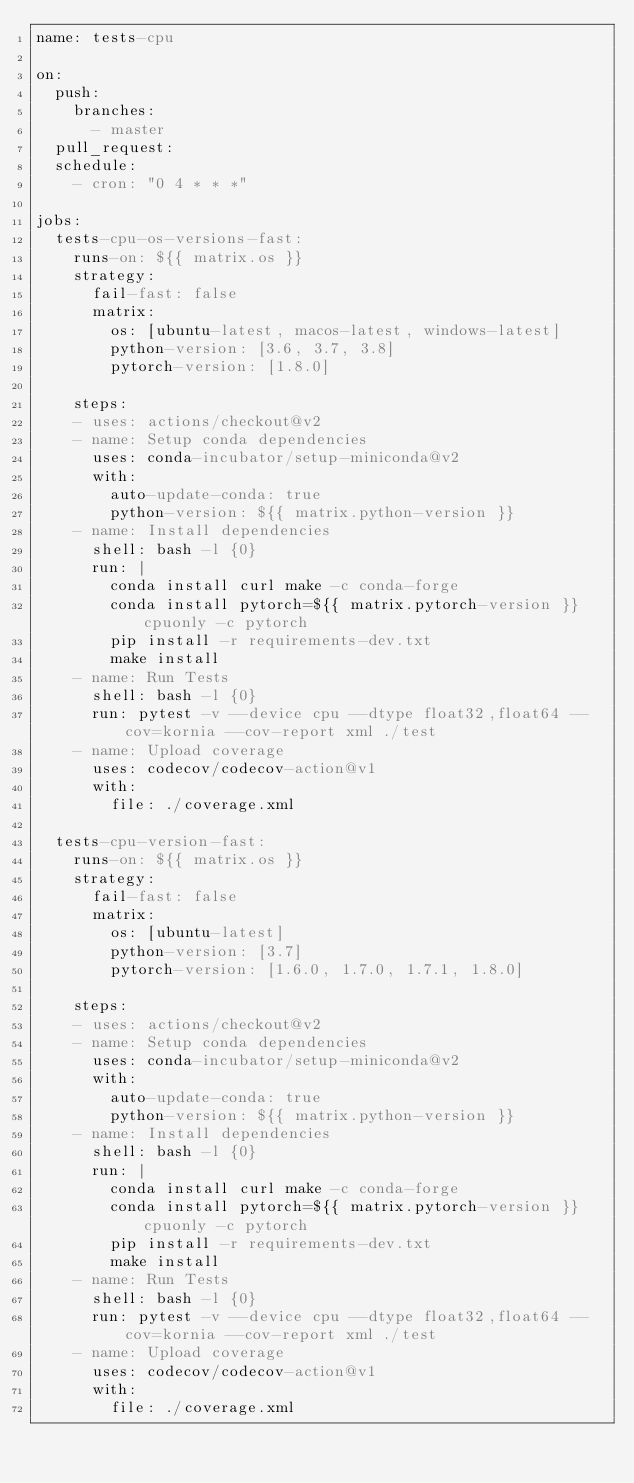Convert code to text. <code><loc_0><loc_0><loc_500><loc_500><_YAML_>name: tests-cpu

on:
  push:
    branches:
      - master
  pull_request:
  schedule:
    - cron: "0 4 * * *"

jobs:
  tests-cpu-os-versions-fast:
    runs-on: ${{ matrix.os }}
    strategy:
      fail-fast: false
      matrix:
        os: [ubuntu-latest, macos-latest, windows-latest]
        python-version: [3.6, 3.7, 3.8]
        pytorch-version: [1.8.0]

    steps:
    - uses: actions/checkout@v2
    - name: Setup conda dependencies
      uses: conda-incubator/setup-miniconda@v2
      with:
        auto-update-conda: true
        python-version: ${{ matrix.python-version }}
    - name: Install dependencies
      shell: bash -l {0}
      run: |
        conda install curl make -c conda-forge
        conda install pytorch=${{ matrix.pytorch-version }} cpuonly -c pytorch
        pip install -r requirements-dev.txt
        make install
    - name: Run Tests
      shell: bash -l {0}
      run: pytest -v --device cpu --dtype float32,float64 --cov=kornia --cov-report xml ./test
    - name: Upload coverage
      uses: codecov/codecov-action@v1
      with:
        file: ./coverage.xml

  tests-cpu-version-fast:
    runs-on: ${{ matrix.os }}
    strategy:
      fail-fast: false
      matrix:
        os: [ubuntu-latest]
        python-version: [3.7]
        pytorch-version: [1.6.0, 1.7.0, 1.7.1, 1.8.0]

    steps:
    - uses: actions/checkout@v2
    - name: Setup conda dependencies
      uses: conda-incubator/setup-miniconda@v2
      with:
        auto-update-conda: true
        python-version: ${{ matrix.python-version }}
    - name: Install dependencies
      shell: bash -l {0}
      run: |
        conda install curl make -c conda-forge
        conda install pytorch=${{ matrix.pytorch-version }} cpuonly -c pytorch
        pip install -r requirements-dev.txt
        make install
    - name: Run Tests
      shell: bash -l {0}
      run: pytest -v --device cpu --dtype float32,float64 --cov=kornia --cov-report xml ./test
    - name: Upload coverage
      uses: codecov/codecov-action@v1
      with:
        file: ./coverage.xml
</code> 